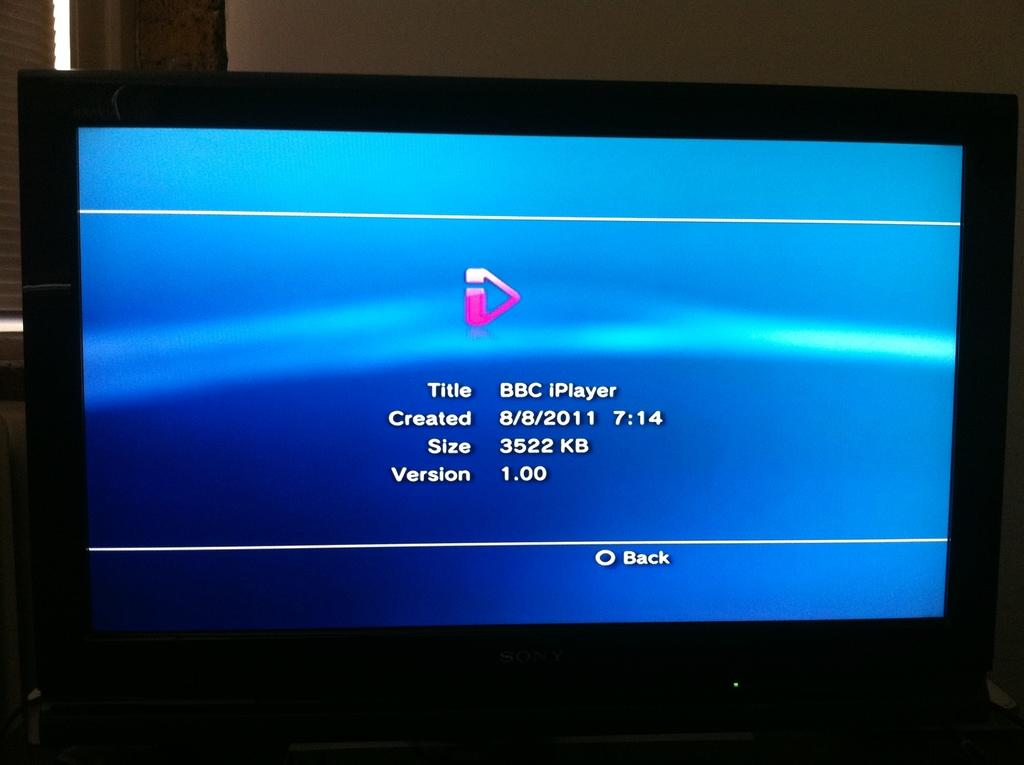What electronic device is present in the image? There is a monitor in the image. What can be seen on the monitor? There is text visible on the monitor. What is visible in the background of the image? There is a wall in the background of the image. What type of seed is being used to make jam in the image? There is no seed or jam present in the image; it only features a monitor with text and a wall in the background. 